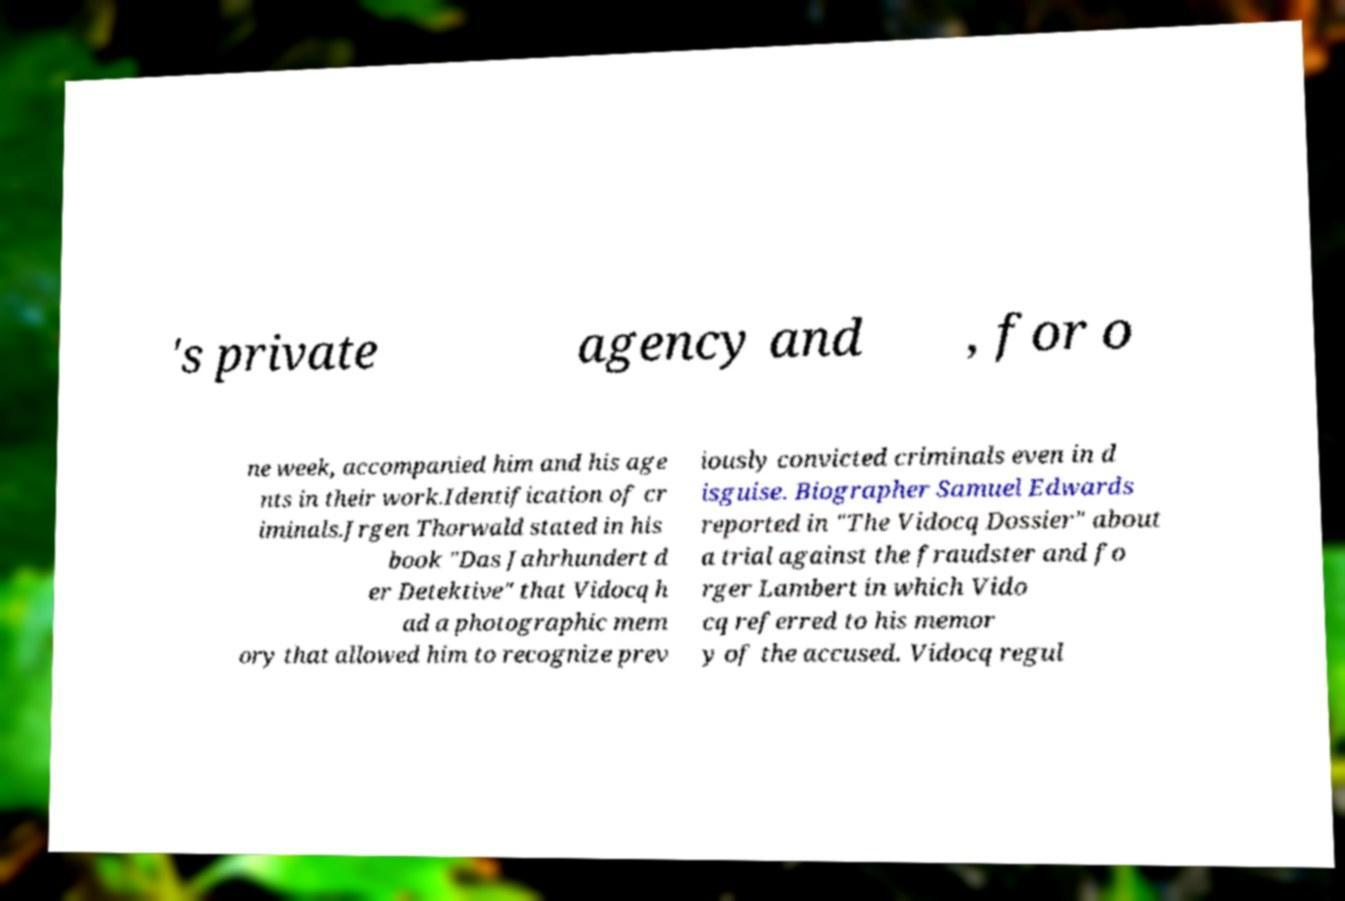Can you read and provide the text displayed in the image?This photo seems to have some interesting text. Can you extract and type it out for me? 's private agency and , for o ne week, accompanied him and his age nts in their work.Identification of cr iminals.Jrgen Thorwald stated in his book "Das Jahrhundert d er Detektive" that Vidocq h ad a photographic mem ory that allowed him to recognize prev iously convicted criminals even in d isguise. Biographer Samuel Edwards reported in "The Vidocq Dossier" about a trial against the fraudster and fo rger Lambert in which Vido cq referred to his memor y of the accused. Vidocq regul 